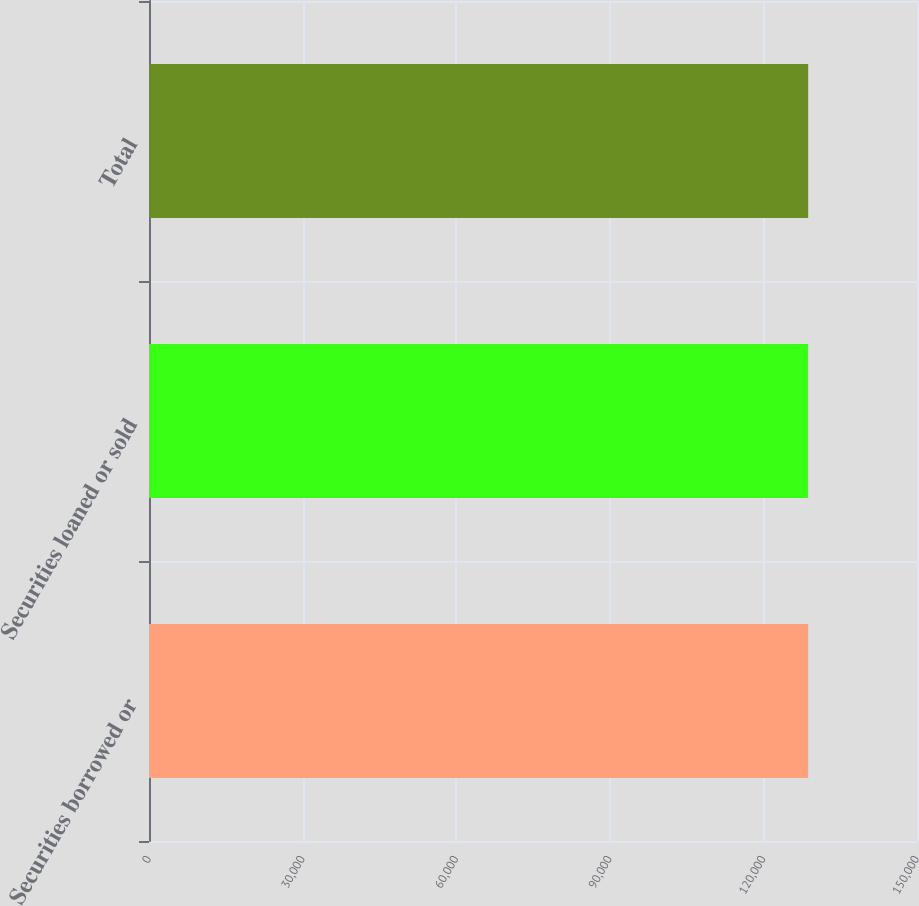Convert chart. <chart><loc_0><loc_0><loc_500><loc_500><bar_chart><fcel>Securities borrowed or<fcel>Securities loaned or sold<fcel>Total<nl><fcel>128746<fcel>128746<fcel>128746<nl></chart> 